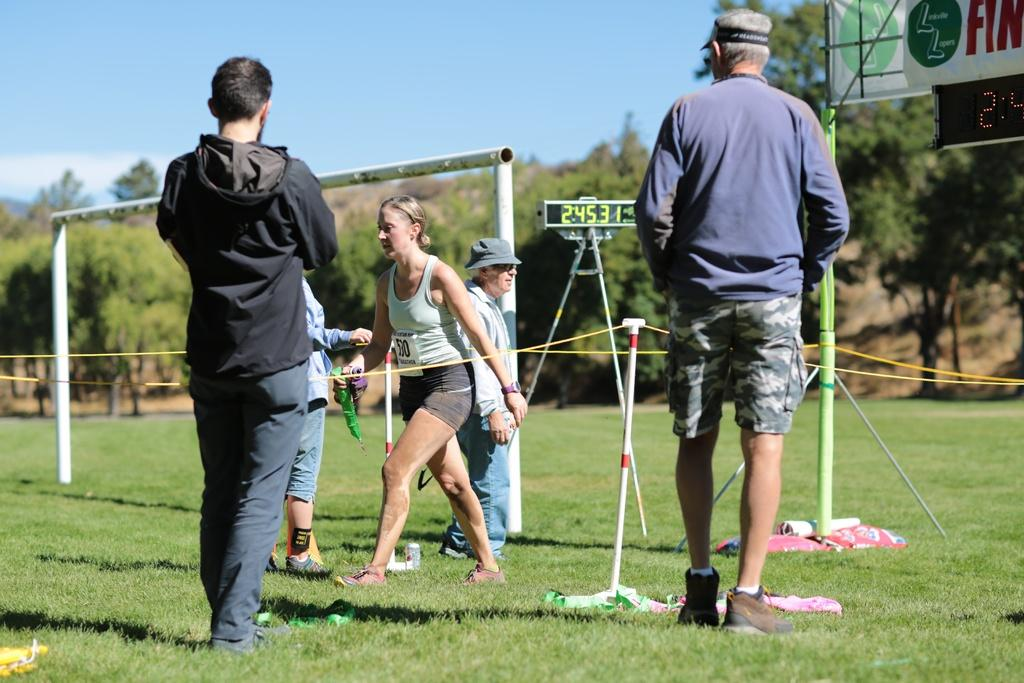<image>
Describe the image concisely. A woman in a teal tank top, with the number 530 on the front is is walking alongside a yellow rope, on a cricket field. 